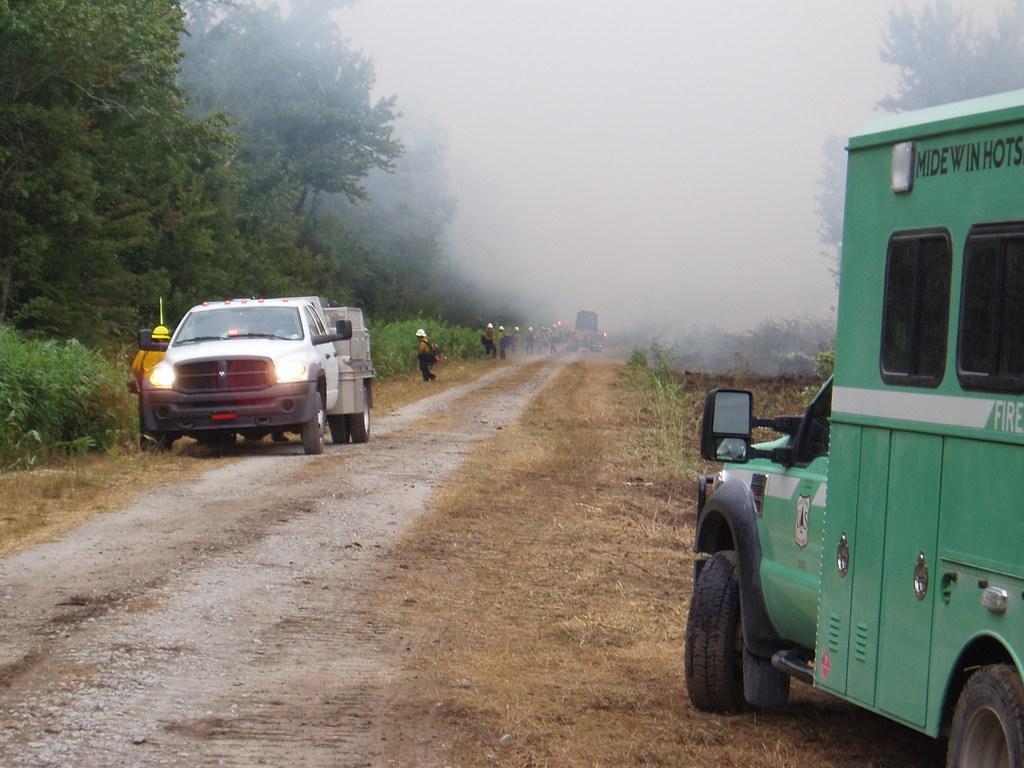Could you give a brief overview of what you see in this image? In this image we can see vehicles, people, plants and trees. 